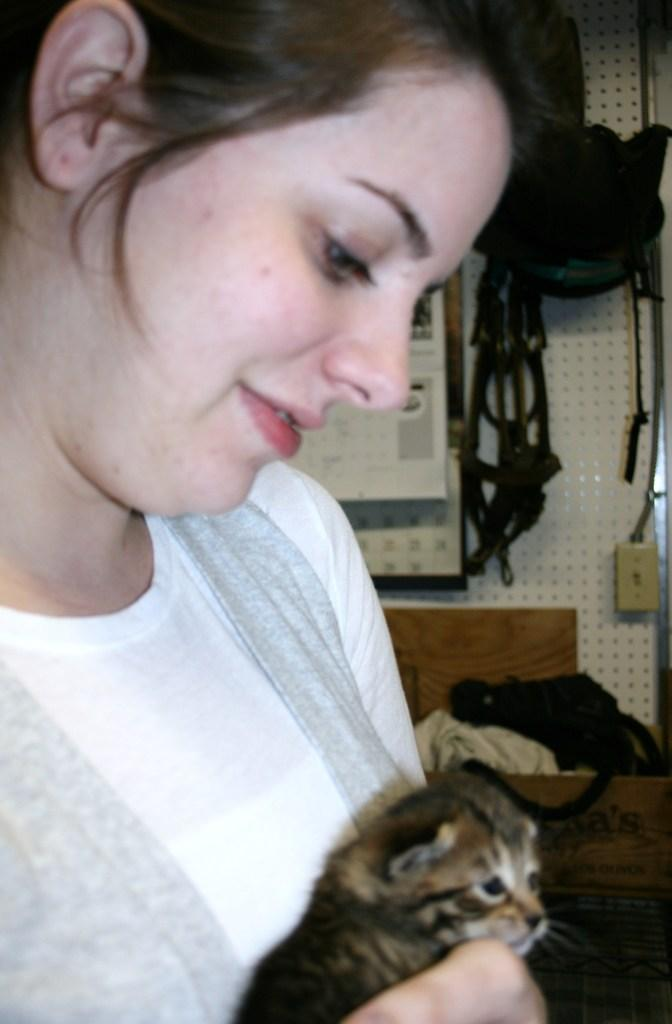Who is present in the image? There is a lady in the image. What is the lady holding? The lady is holding a cat. What can be seen hanging in the background? There are bags hanging in the background. What is placed on the wall in the background? There is a board placed on the wall in the background. What type of furniture is visible in the background? There is a cot in the background. What type of quilt is being used to cover the bone in the image? There is no quilt or bone present in the image. 